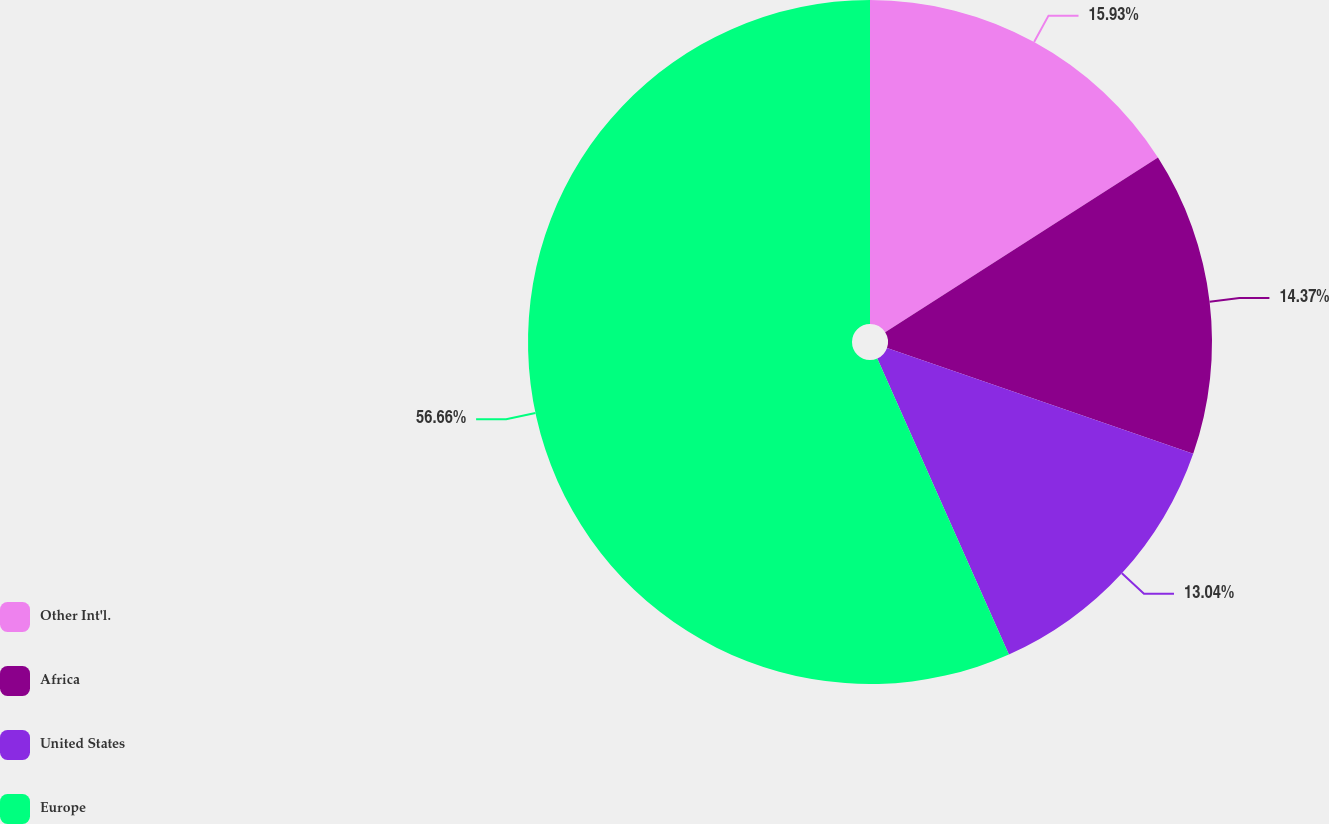Convert chart to OTSL. <chart><loc_0><loc_0><loc_500><loc_500><pie_chart><fcel>Other Int'l.<fcel>Africa<fcel>United States<fcel>Europe<nl><fcel>15.93%<fcel>14.37%<fcel>13.04%<fcel>56.65%<nl></chart> 